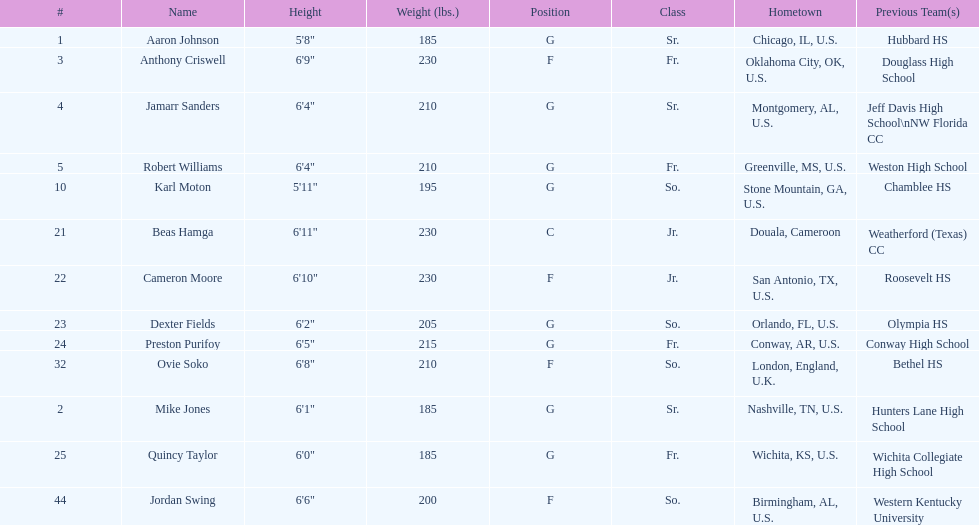Would you be able to parse every entry in this table? {'header': ['#', 'Name', 'Height', 'Weight (lbs.)', 'Position', 'Class', 'Hometown', 'Previous Team(s)'], 'rows': [['1', 'Aaron Johnson', '5\'8"', '185', 'G', 'Sr.', 'Chicago, IL, U.S.', 'Hubbard HS'], ['3', 'Anthony Criswell', '6\'9"', '230', 'F', 'Fr.', 'Oklahoma City, OK, U.S.', 'Douglass High School'], ['4', 'Jamarr Sanders', '6\'4"', '210', 'G', 'Sr.', 'Montgomery, AL, U.S.', 'Jeff Davis High School\\nNW Florida CC'], ['5', 'Robert Williams', '6\'4"', '210', 'G', 'Fr.', 'Greenville, MS, U.S.', 'Weston High School'], ['10', 'Karl Moton', '5\'11"', '195', 'G', 'So.', 'Stone Mountain, GA, U.S.', 'Chamblee HS'], ['21', 'Beas Hamga', '6\'11"', '230', 'C', 'Jr.', 'Douala, Cameroon', 'Weatherford (Texas) CC'], ['22', 'Cameron Moore', '6\'10"', '230', 'F', 'Jr.', 'San Antonio, TX, U.S.', 'Roosevelt HS'], ['23', 'Dexter Fields', '6\'2"', '205', 'G', 'So.', 'Orlando, FL, U.S.', 'Olympia HS'], ['24', 'Preston Purifoy', '6\'5"', '215', 'G', 'Fr.', 'Conway, AR, U.S.', 'Conway High School'], ['32', 'Ovie Soko', '6\'8"', '210', 'F', 'So.', 'London, England, U.K.', 'Bethel HS'], ['2', 'Mike Jones', '6\'1"', '185', 'G', 'Sr.', 'Nashville, TN, U.S.', 'Hunters Lane High School'], ['25', 'Quincy Taylor', '6\'0"', '185', 'G', 'Fr.', 'Wichita, KS, U.S.', 'Wichita Collegiate High School'], ['44', 'Jordan Swing', '6\'6"', '200', 'F', 'So.', 'Birmingham, AL, U.S.', 'Western Kentucky University']]} Tell me the number of juniors on the team. 2. 